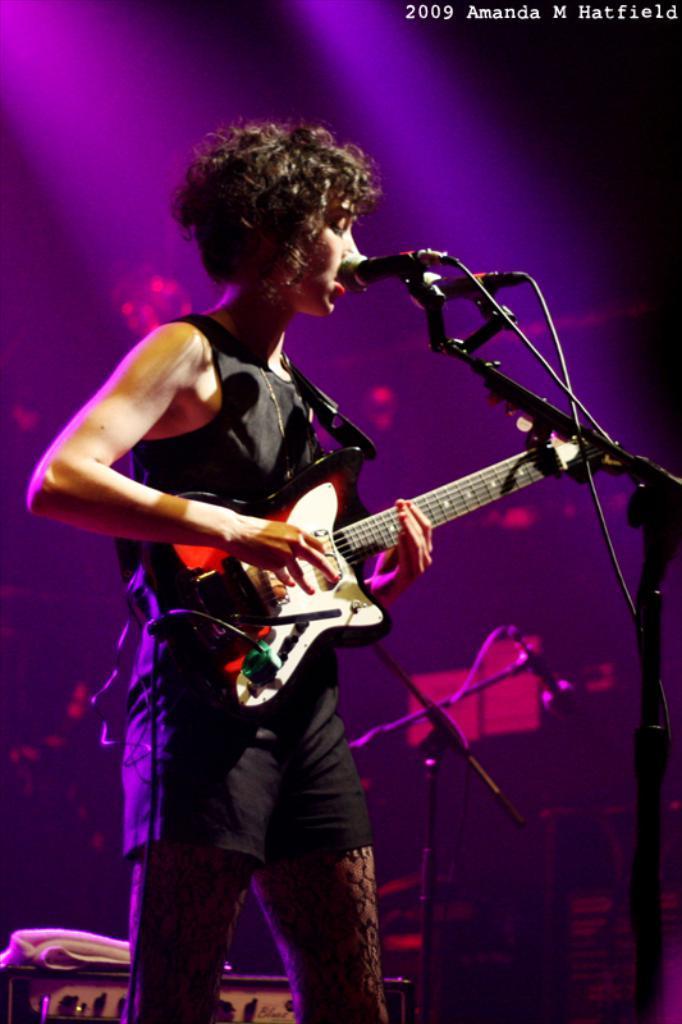How would you summarize this image in a sentence or two? In the picture we can see a person wearing black color dress standing and playing guitar, there is microphone and in the background of the picture there are some other objects. 